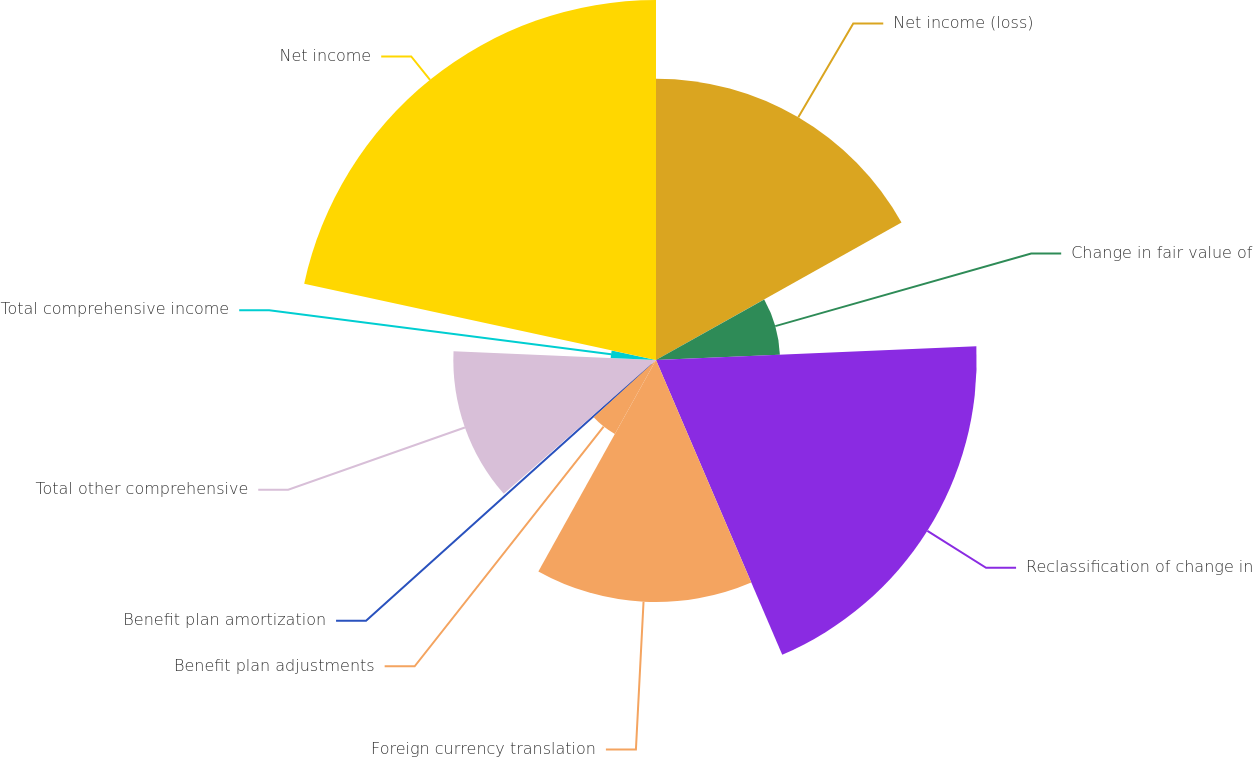Convert chart. <chart><loc_0><loc_0><loc_500><loc_500><pie_chart><fcel>Net income (loss)<fcel>Change in fair value of<fcel>Reclassification of change in<fcel>Foreign currency translation<fcel>Benefit plan adjustments<fcel>Benefit plan amortization<fcel>Total other comprehensive<fcel>Total comprehensive income<fcel>Net income<nl><fcel>16.88%<fcel>7.44%<fcel>19.24%<fcel>14.52%<fcel>5.08%<fcel>0.36%<fcel>12.16%<fcel>2.72%<fcel>21.6%<nl></chart> 